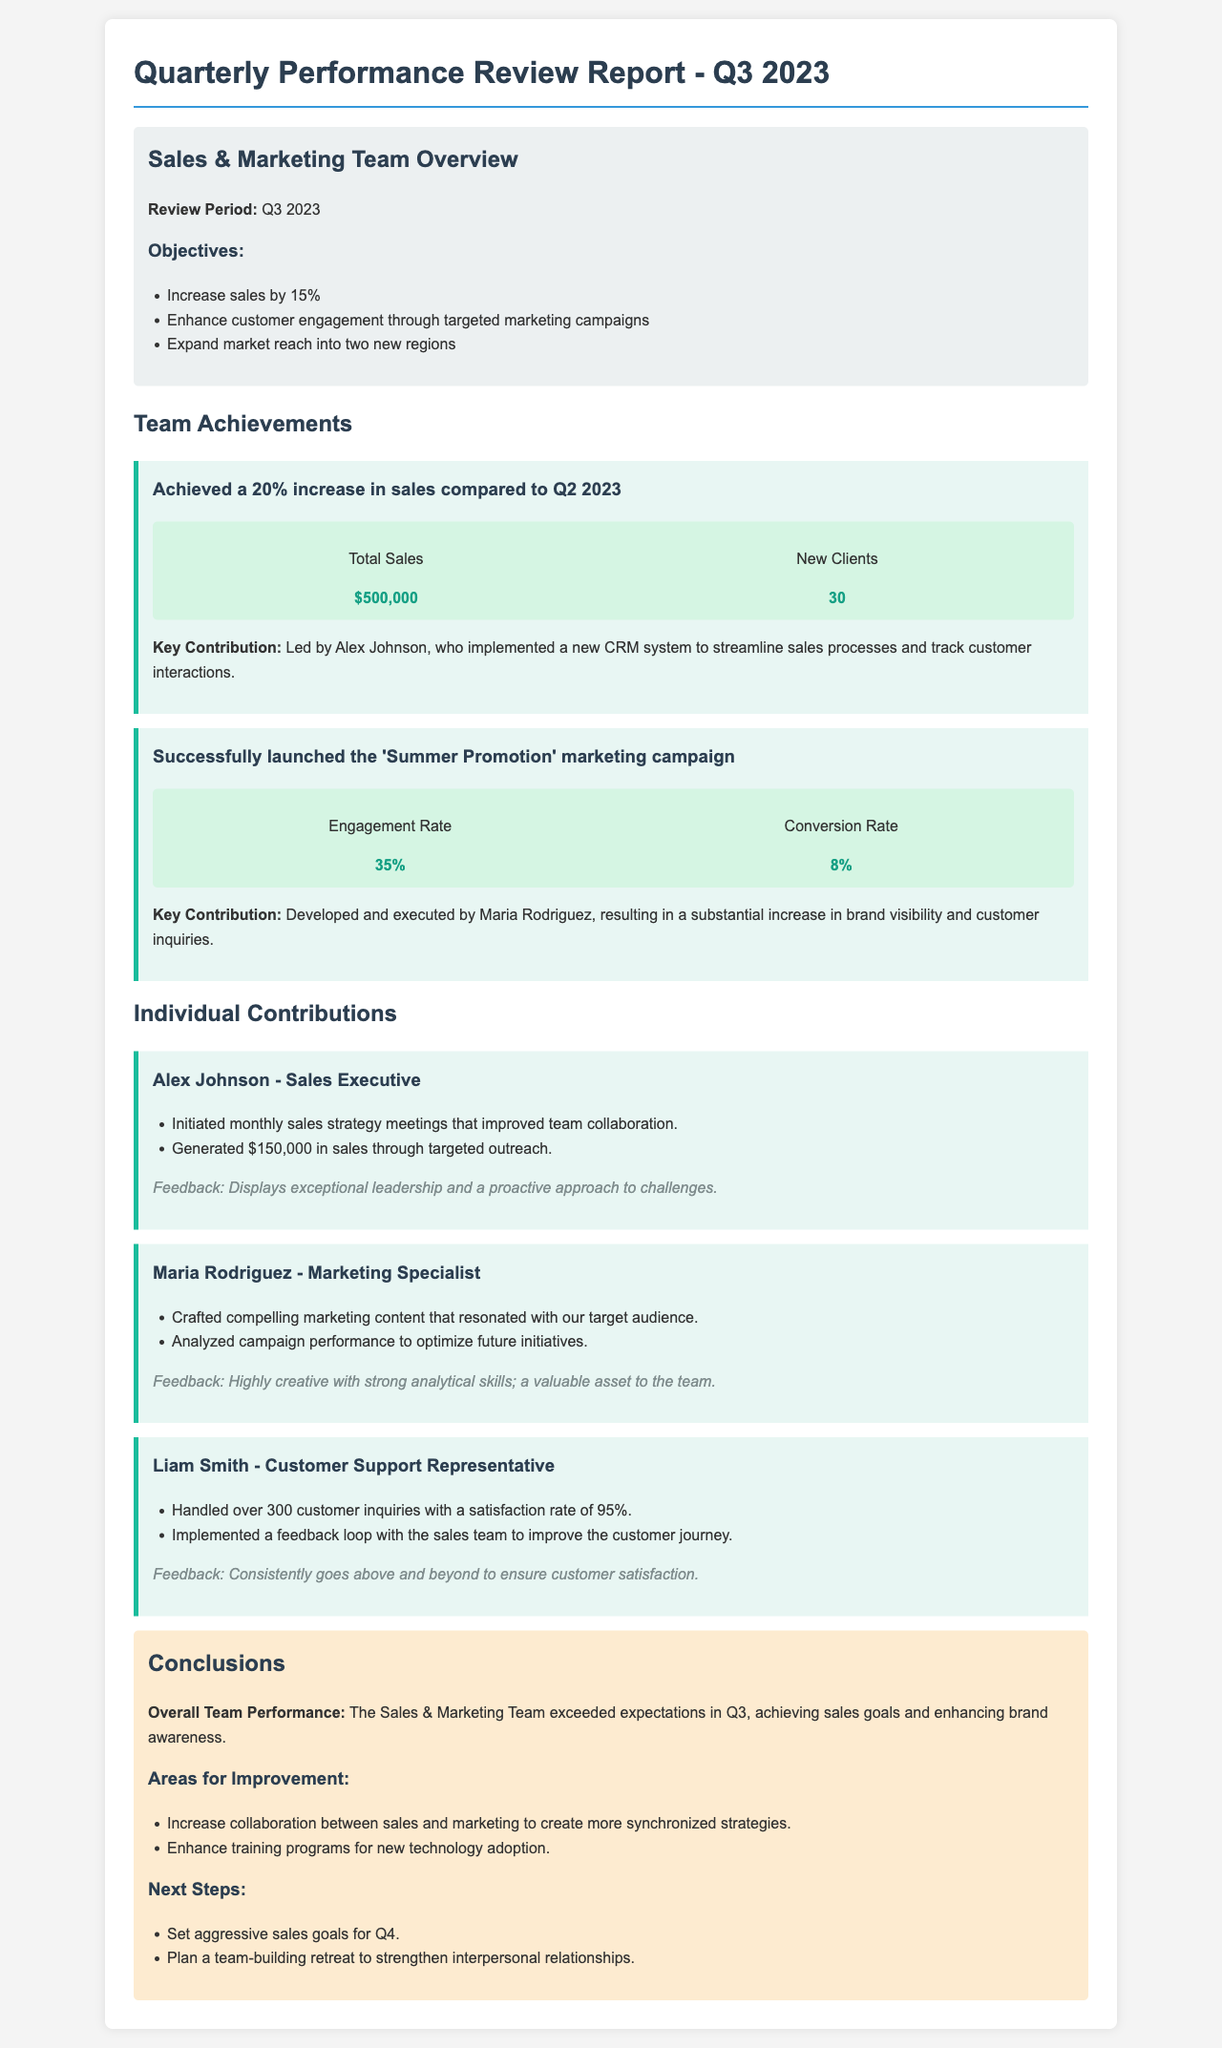What was the review period for the report? The review period is explicitly mentioned in the document as Q3 2023.
Answer: Q3 2023 What was the percentage increase in sales compared to Q2 2023? The document states a 20% increase in sales compared to Q2 2023.
Answer: 20% Who led the new CRM system implementation? The document specifies that Alex Johnson led the implementation of the new CRM system.
Answer: Alex Johnson What was the engagement rate for the 'Summer Promotion' marketing campaign? The engagement rate is given as 35% in the document.
Answer: 35% What area needs improvement according to the conclusions? The document points out the need to increase collaboration between sales and marketing.
Answer: Increase collaboration between sales and marketing How many customer inquiries did Liam Smith handle? The document mentions that Liam Smith handled over 300 customer inquiries.
Answer: Over 300 What was Maria Rodriguez's primary contribution according to the achievements section? The document states that Maria Rodriguez developed and executed the 'Summer Promotion' marketing campaign.
Answer: Developed and executed the 'Summer Promotion' marketing campaign What is the total sales amount reported in the achievements? The total sales amount reported is $500,000.
Answer: $500,000 What is one of the next steps outlined for the team? The document outlines setting aggressive sales goals for Q4 as one of the next steps.
Answer: Set aggressive sales goals for Q4 